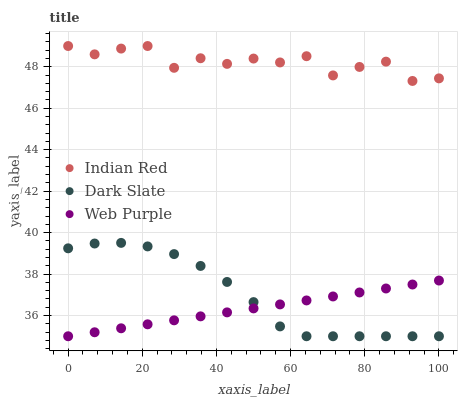Does Web Purple have the minimum area under the curve?
Answer yes or no. Yes. Does Indian Red have the maximum area under the curve?
Answer yes or no. Yes. Does Indian Red have the minimum area under the curve?
Answer yes or no. No. Does Web Purple have the maximum area under the curve?
Answer yes or no. No. Is Web Purple the smoothest?
Answer yes or no. Yes. Is Indian Red the roughest?
Answer yes or no. Yes. Is Indian Red the smoothest?
Answer yes or no. No. Is Web Purple the roughest?
Answer yes or no. No. Does Dark Slate have the lowest value?
Answer yes or no. Yes. Does Indian Red have the lowest value?
Answer yes or no. No. Does Indian Red have the highest value?
Answer yes or no. Yes. Does Web Purple have the highest value?
Answer yes or no. No. Is Web Purple less than Indian Red?
Answer yes or no. Yes. Is Indian Red greater than Web Purple?
Answer yes or no. Yes. Does Dark Slate intersect Web Purple?
Answer yes or no. Yes. Is Dark Slate less than Web Purple?
Answer yes or no. No. Is Dark Slate greater than Web Purple?
Answer yes or no. No. Does Web Purple intersect Indian Red?
Answer yes or no. No. 